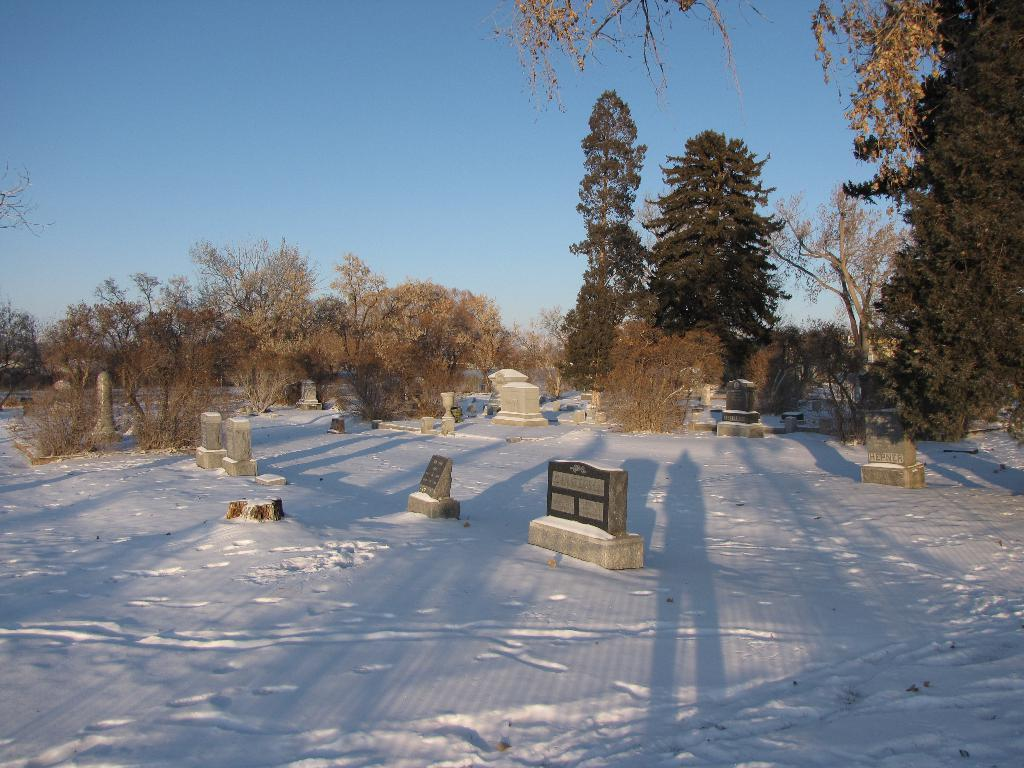What is the main subject in the center of the image? There are graveyards in the center of the image. What can be seen in the background of the image? There is sky, clouds, trees, and plants visible in the background of the image. What type of reaction can be seen from the cook in the image? There is no cook present in the image, so it is not possible to determine any reactions. 